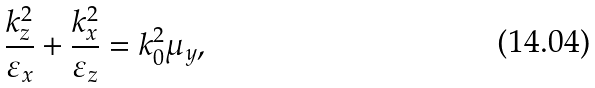<formula> <loc_0><loc_0><loc_500><loc_500>\frac { k _ { z } ^ { 2 } } { \varepsilon _ { x } } + \frac { k _ { x } ^ { 2 } } { \varepsilon _ { z } } = k _ { 0 } ^ { 2 } \mu _ { y } ,</formula> 